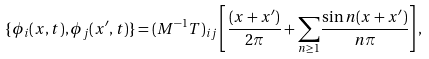Convert formula to latex. <formula><loc_0><loc_0><loc_500><loc_500>\{ \phi _ { i } ( x , t ) , \phi _ { j } ( x ^ { \prime } , t ) \} = ( M ^ { - 1 } T ) _ { i j } \left [ \frac { ( x + x ^ { \prime } ) } { 2 \pi } + { \sum _ { n \geq 1 } } \frac { \sin n ( x + x ^ { \prime } ) } { n \pi } \right ] ,</formula> 